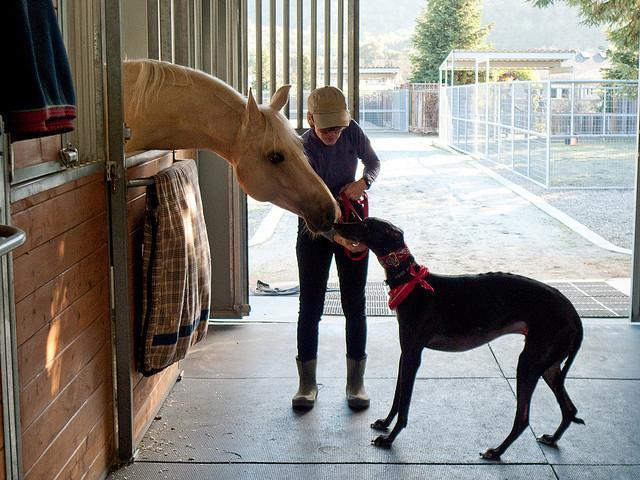How many chairs are there?
Give a very brief answer. 0. 